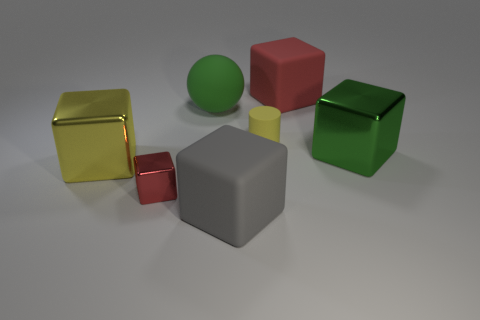The big shiny thing that is right of the large rubber sphere has what shape?
Make the answer very short. Cube. There is a sphere that is the same size as the gray rubber object; what is its color?
Offer a very short reply. Green. Are the large green thing to the left of the gray matte object and the large gray cube made of the same material?
Ensure brevity in your answer.  Yes. How big is the block that is behind the gray rubber object and in front of the large yellow metal block?
Provide a succinct answer. Small. How big is the red cube on the right side of the big gray cube?
Your answer should be very brief. Large. What is the shape of the other object that is the same color as the tiny rubber object?
Make the answer very short. Cube. What is the shape of the red object that is behind the big green thing that is behind the metallic cube to the right of the tiny metallic cube?
Your answer should be compact. Cube. How many other things are there of the same shape as the big red thing?
Make the answer very short. 4. How many matte objects are either large green cubes or blue balls?
Offer a very short reply. 0. What material is the green object that is to the left of the large red cube that is behind the large gray rubber thing?
Offer a very short reply. Rubber. 